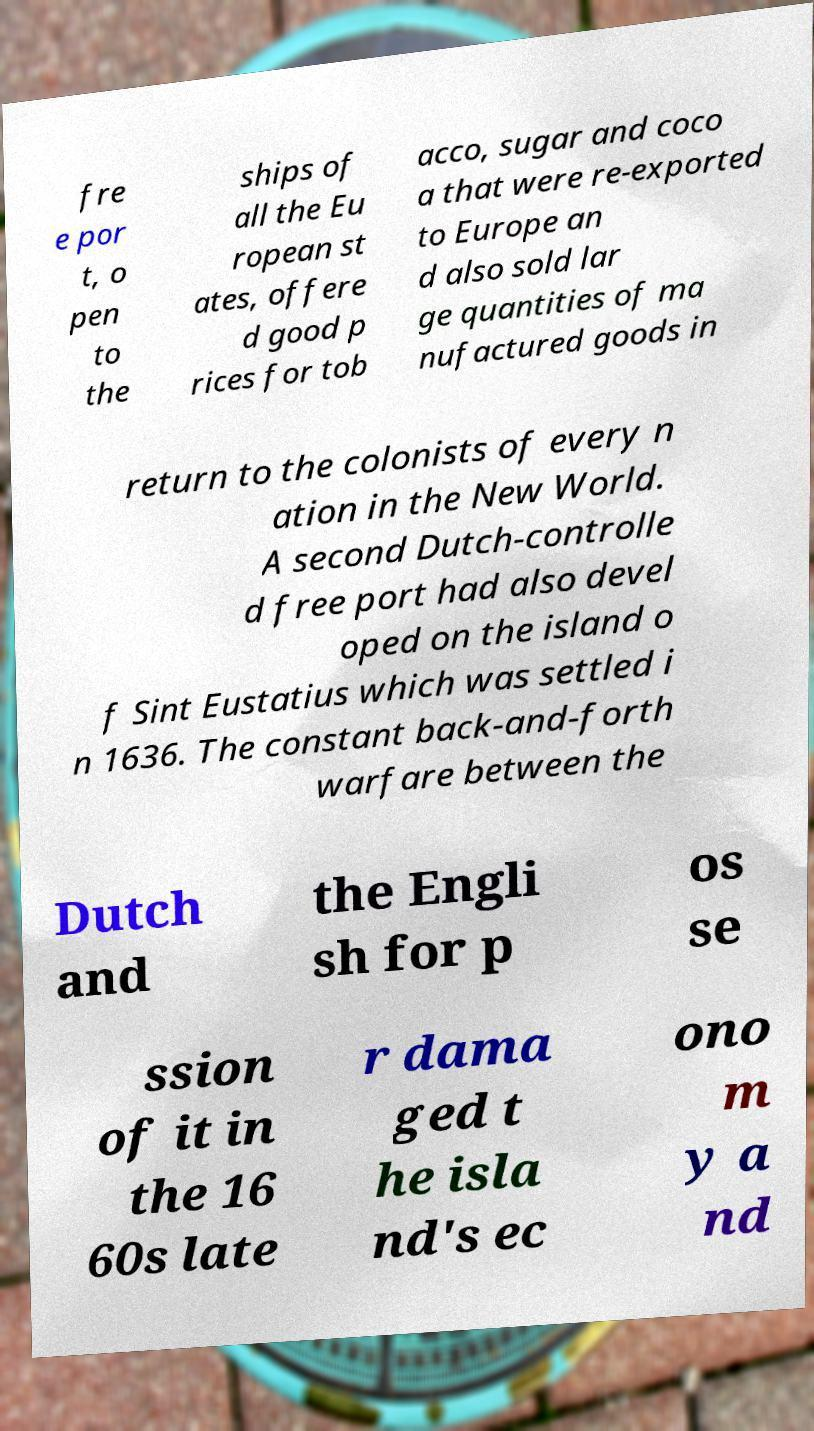Can you read and provide the text displayed in the image?This photo seems to have some interesting text. Can you extract and type it out for me? fre e por t, o pen to the ships of all the Eu ropean st ates, offere d good p rices for tob acco, sugar and coco a that were re-exported to Europe an d also sold lar ge quantities of ma nufactured goods in return to the colonists of every n ation in the New World. A second Dutch-controlle d free port had also devel oped on the island o f Sint Eustatius which was settled i n 1636. The constant back-and-forth warfare between the Dutch and the Engli sh for p os se ssion of it in the 16 60s late r dama ged t he isla nd's ec ono m y a nd 